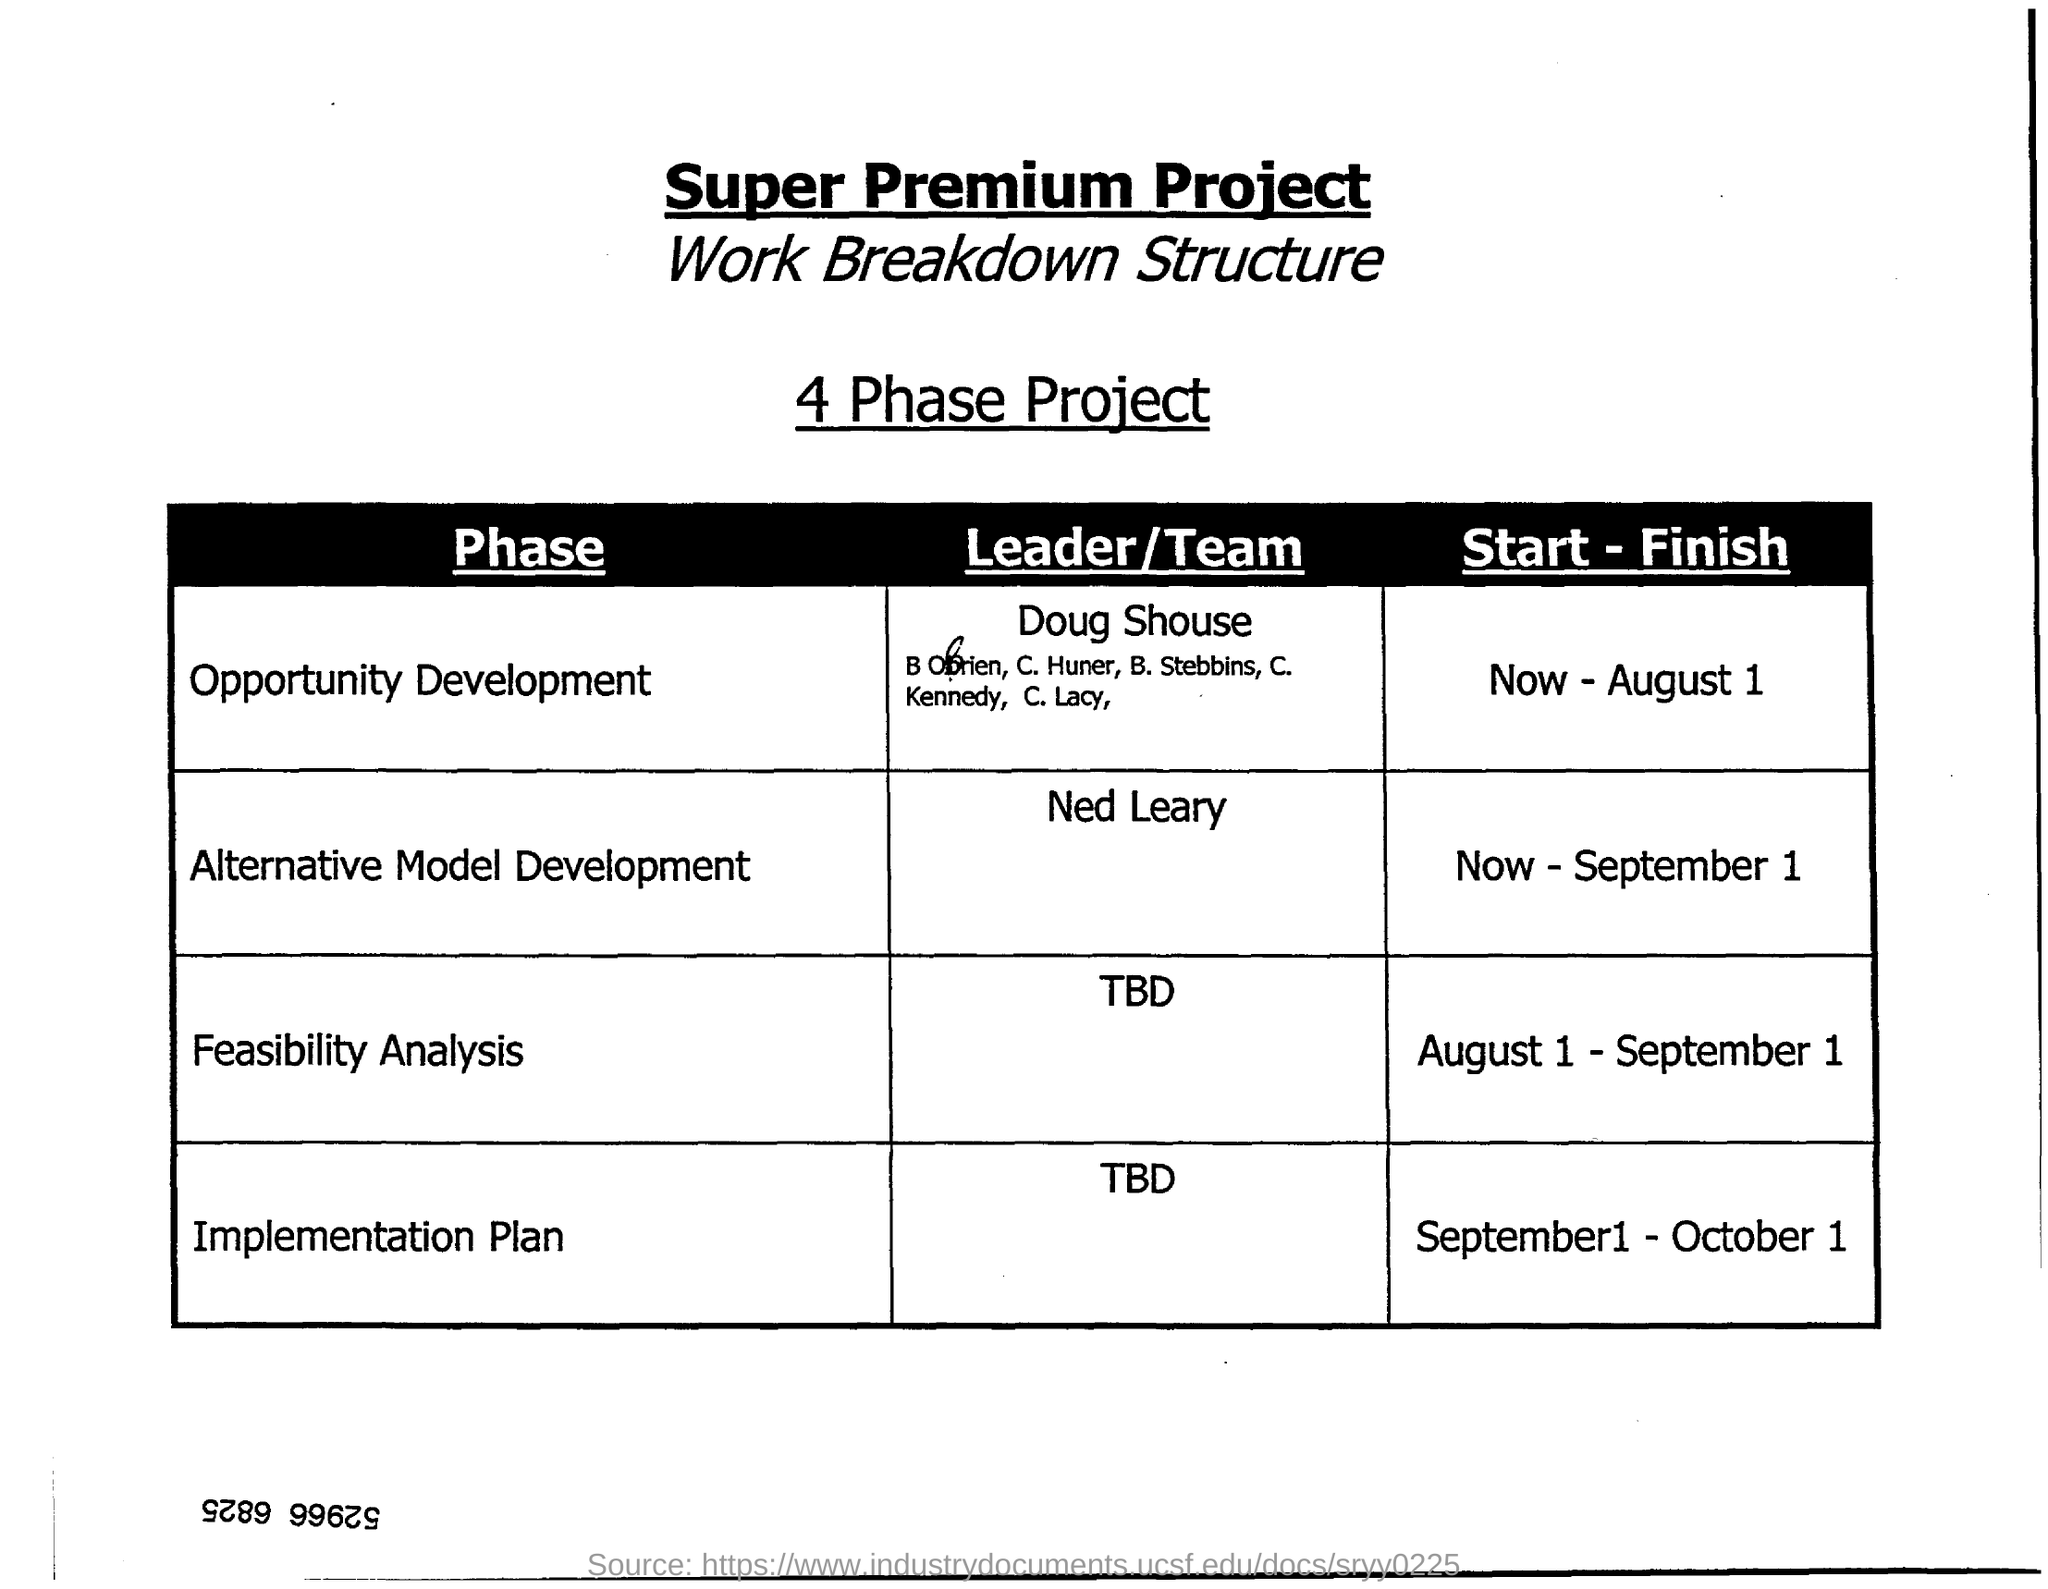Specify some key components in this picture. Ned Leary is the leader or team responsible for the development of the alternative model. The feasibility analysis for a project is scheduled to begin on August 1 and conclude on September 1. 